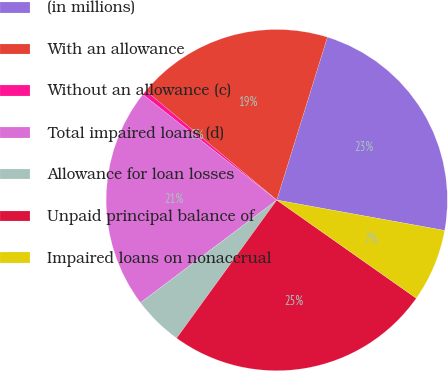<chart> <loc_0><loc_0><loc_500><loc_500><pie_chart><fcel>(in millions)<fcel>With an allowance<fcel>Without an allowance (c)<fcel>Total impaired loans (d)<fcel>Allowance for loan losses<fcel>Unpaid principal balance of<fcel>Impaired loans on nonaccrual<nl><fcel>23.06%<fcel>18.73%<fcel>0.44%<fcel>20.9%<fcel>4.74%<fcel>25.23%<fcel>6.91%<nl></chart> 